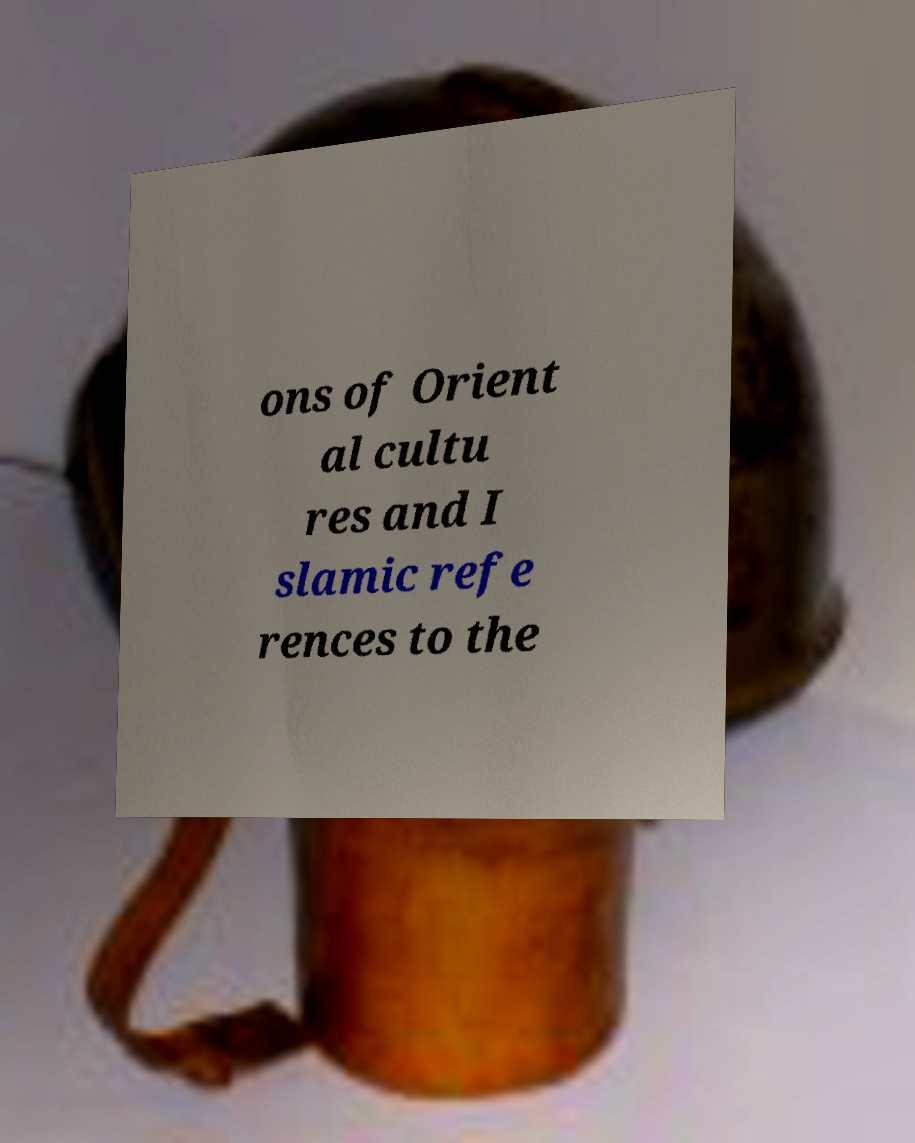What messages or text are displayed in this image? I need them in a readable, typed format. ons of Orient al cultu res and I slamic refe rences to the 